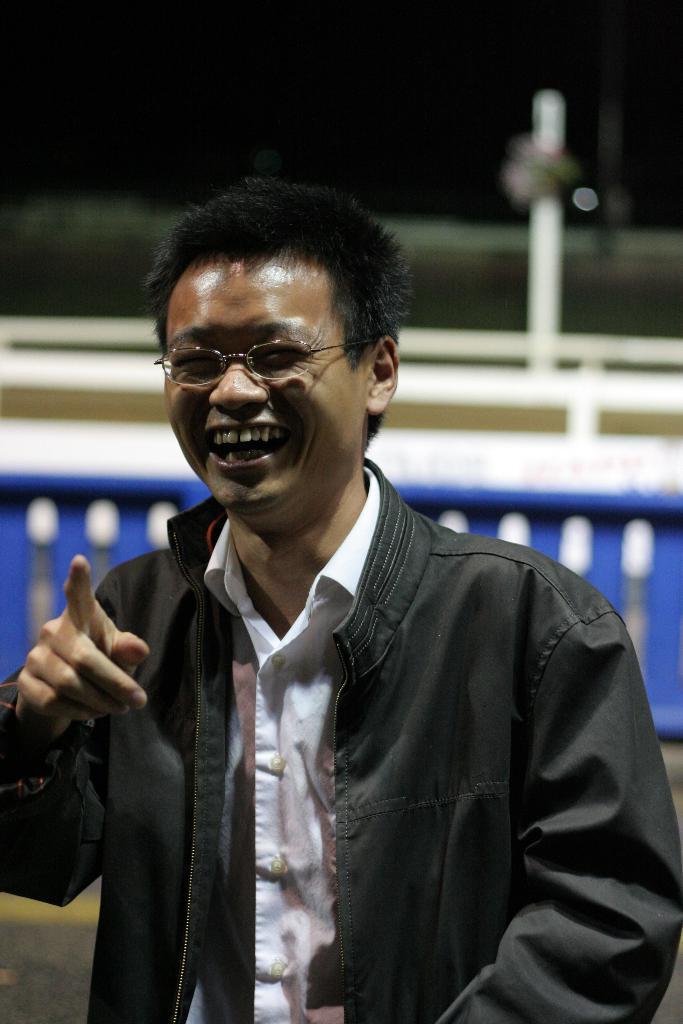In one or two sentences, can you explain what this image depicts? In this image I can see the person is wearing white color shirt and black color jacket. I can see the blue color fencing and the blurred background. 